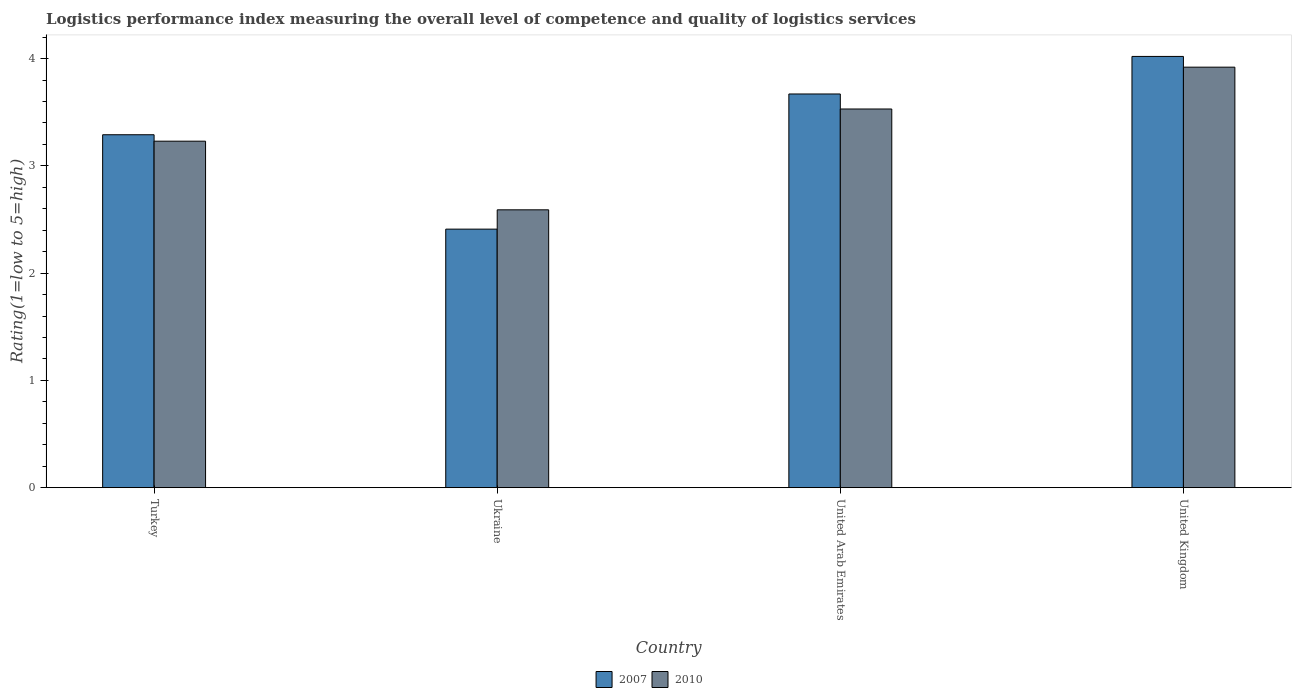How many different coloured bars are there?
Keep it short and to the point. 2. How many groups of bars are there?
Ensure brevity in your answer.  4. Are the number of bars per tick equal to the number of legend labels?
Give a very brief answer. Yes. How many bars are there on the 3rd tick from the left?
Offer a very short reply. 2. How many bars are there on the 1st tick from the right?
Ensure brevity in your answer.  2. What is the label of the 1st group of bars from the left?
Your answer should be compact. Turkey. In how many cases, is the number of bars for a given country not equal to the number of legend labels?
Your answer should be very brief. 0. What is the Logistic performance index in 2010 in United Kingdom?
Offer a very short reply. 3.92. Across all countries, what is the maximum Logistic performance index in 2007?
Give a very brief answer. 4.02. Across all countries, what is the minimum Logistic performance index in 2010?
Your response must be concise. 2.59. In which country was the Logistic performance index in 2010 maximum?
Provide a succinct answer. United Kingdom. In which country was the Logistic performance index in 2010 minimum?
Your response must be concise. Ukraine. What is the total Logistic performance index in 2007 in the graph?
Ensure brevity in your answer.  13.39. What is the difference between the Logistic performance index in 2010 in Turkey and that in United Arab Emirates?
Provide a short and direct response. -0.3. What is the difference between the Logistic performance index in 2010 in Turkey and the Logistic performance index in 2007 in United Kingdom?
Ensure brevity in your answer.  -0.79. What is the average Logistic performance index in 2007 per country?
Make the answer very short. 3.35. What is the difference between the Logistic performance index of/in 2007 and Logistic performance index of/in 2010 in Turkey?
Ensure brevity in your answer.  0.06. In how many countries, is the Logistic performance index in 2010 greater than 3.6?
Give a very brief answer. 1. What is the ratio of the Logistic performance index in 2007 in Ukraine to that in United Kingdom?
Provide a succinct answer. 0.6. Is the Logistic performance index in 2010 in Turkey less than that in United Arab Emirates?
Offer a very short reply. Yes. What is the difference between the highest and the second highest Logistic performance index in 2010?
Keep it short and to the point. -0.39. What is the difference between the highest and the lowest Logistic performance index in 2010?
Ensure brevity in your answer.  1.33. Is the sum of the Logistic performance index in 2010 in Turkey and Ukraine greater than the maximum Logistic performance index in 2007 across all countries?
Give a very brief answer. Yes. What does the 2nd bar from the left in Turkey represents?
Make the answer very short. 2010. What does the 2nd bar from the right in United Kingdom represents?
Offer a very short reply. 2007. How many bars are there?
Provide a succinct answer. 8. Are all the bars in the graph horizontal?
Your answer should be very brief. No. How many legend labels are there?
Keep it short and to the point. 2. How are the legend labels stacked?
Ensure brevity in your answer.  Horizontal. What is the title of the graph?
Your response must be concise. Logistics performance index measuring the overall level of competence and quality of logistics services. Does "1970" appear as one of the legend labels in the graph?
Provide a succinct answer. No. What is the label or title of the X-axis?
Keep it short and to the point. Country. What is the label or title of the Y-axis?
Offer a terse response. Rating(1=low to 5=high). What is the Rating(1=low to 5=high) of 2007 in Turkey?
Keep it short and to the point. 3.29. What is the Rating(1=low to 5=high) of 2010 in Turkey?
Offer a terse response. 3.23. What is the Rating(1=low to 5=high) in 2007 in Ukraine?
Offer a very short reply. 2.41. What is the Rating(1=low to 5=high) in 2010 in Ukraine?
Provide a short and direct response. 2.59. What is the Rating(1=low to 5=high) in 2007 in United Arab Emirates?
Keep it short and to the point. 3.67. What is the Rating(1=low to 5=high) of 2010 in United Arab Emirates?
Offer a very short reply. 3.53. What is the Rating(1=low to 5=high) of 2007 in United Kingdom?
Ensure brevity in your answer.  4.02. What is the Rating(1=low to 5=high) of 2010 in United Kingdom?
Make the answer very short. 3.92. Across all countries, what is the maximum Rating(1=low to 5=high) of 2007?
Provide a short and direct response. 4.02. Across all countries, what is the maximum Rating(1=low to 5=high) in 2010?
Provide a succinct answer. 3.92. Across all countries, what is the minimum Rating(1=low to 5=high) in 2007?
Ensure brevity in your answer.  2.41. Across all countries, what is the minimum Rating(1=low to 5=high) in 2010?
Provide a short and direct response. 2.59. What is the total Rating(1=low to 5=high) of 2007 in the graph?
Offer a very short reply. 13.39. What is the total Rating(1=low to 5=high) in 2010 in the graph?
Keep it short and to the point. 13.27. What is the difference between the Rating(1=low to 5=high) of 2007 in Turkey and that in Ukraine?
Give a very brief answer. 0.88. What is the difference between the Rating(1=low to 5=high) of 2010 in Turkey and that in Ukraine?
Offer a terse response. 0.64. What is the difference between the Rating(1=low to 5=high) of 2007 in Turkey and that in United Arab Emirates?
Your answer should be compact. -0.38. What is the difference between the Rating(1=low to 5=high) in 2007 in Turkey and that in United Kingdom?
Give a very brief answer. -0.73. What is the difference between the Rating(1=low to 5=high) in 2010 in Turkey and that in United Kingdom?
Ensure brevity in your answer.  -0.69. What is the difference between the Rating(1=low to 5=high) of 2007 in Ukraine and that in United Arab Emirates?
Your answer should be compact. -1.26. What is the difference between the Rating(1=low to 5=high) of 2010 in Ukraine and that in United Arab Emirates?
Your response must be concise. -0.94. What is the difference between the Rating(1=low to 5=high) in 2007 in Ukraine and that in United Kingdom?
Provide a succinct answer. -1.61. What is the difference between the Rating(1=low to 5=high) of 2010 in Ukraine and that in United Kingdom?
Your response must be concise. -1.33. What is the difference between the Rating(1=low to 5=high) in 2007 in United Arab Emirates and that in United Kingdom?
Make the answer very short. -0.35. What is the difference between the Rating(1=low to 5=high) in 2010 in United Arab Emirates and that in United Kingdom?
Offer a very short reply. -0.39. What is the difference between the Rating(1=low to 5=high) of 2007 in Turkey and the Rating(1=low to 5=high) of 2010 in Ukraine?
Provide a short and direct response. 0.7. What is the difference between the Rating(1=low to 5=high) in 2007 in Turkey and the Rating(1=low to 5=high) in 2010 in United Arab Emirates?
Make the answer very short. -0.24. What is the difference between the Rating(1=low to 5=high) of 2007 in Turkey and the Rating(1=low to 5=high) of 2010 in United Kingdom?
Offer a terse response. -0.63. What is the difference between the Rating(1=low to 5=high) in 2007 in Ukraine and the Rating(1=low to 5=high) in 2010 in United Arab Emirates?
Give a very brief answer. -1.12. What is the difference between the Rating(1=low to 5=high) in 2007 in Ukraine and the Rating(1=low to 5=high) in 2010 in United Kingdom?
Your answer should be compact. -1.51. What is the difference between the Rating(1=low to 5=high) of 2007 in United Arab Emirates and the Rating(1=low to 5=high) of 2010 in United Kingdom?
Offer a terse response. -0.25. What is the average Rating(1=low to 5=high) in 2007 per country?
Your answer should be compact. 3.35. What is the average Rating(1=low to 5=high) of 2010 per country?
Keep it short and to the point. 3.32. What is the difference between the Rating(1=low to 5=high) in 2007 and Rating(1=low to 5=high) in 2010 in Ukraine?
Your response must be concise. -0.18. What is the difference between the Rating(1=low to 5=high) of 2007 and Rating(1=low to 5=high) of 2010 in United Arab Emirates?
Offer a terse response. 0.14. What is the ratio of the Rating(1=low to 5=high) of 2007 in Turkey to that in Ukraine?
Your answer should be compact. 1.37. What is the ratio of the Rating(1=low to 5=high) of 2010 in Turkey to that in Ukraine?
Offer a very short reply. 1.25. What is the ratio of the Rating(1=low to 5=high) of 2007 in Turkey to that in United Arab Emirates?
Your answer should be compact. 0.9. What is the ratio of the Rating(1=low to 5=high) of 2010 in Turkey to that in United Arab Emirates?
Provide a short and direct response. 0.92. What is the ratio of the Rating(1=low to 5=high) of 2007 in Turkey to that in United Kingdom?
Provide a succinct answer. 0.82. What is the ratio of the Rating(1=low to 5=high) of 2010 in Turkey to that in United Kingdom?
Your response must be concise. 0.82. What is the ratio of the Rating(1=low to 5=high) in 2007 in Ukraine to that in United Arab Emirates?
Keep it short and to the point. 0.66. What is the ratio of the Rating(1=low to 5=high) in 2010 in Ukraine to that in United Arab Emirates?
Offer a very short reply. 0.73. What is the ratio of the Rating(1=low to 5=high) of 2007 in Ukraine to that in United Kingdom?
Offer a very short reply. 0.6. What is the ratio of the Rating(1=low to 5=high) in 2010 in Ukraine to that in United Kingdom?
Offer a terse response. 0.66. What is the ratio of the Rating(1=low to 5=high) in 2007 in United Arab Emirates to that in United Kingdom?
Provide a short and direct response. 0.91. What is the ratio of the Rating(1=low to 5=high) in 2010 in United Arab Emirates to that in United Kingdom?
Offer a very short reply. 0.9. What is the difference between the highest and the second highest Rating(1=low to 5=high) of 2007?
Give a very brief answer. 0.35. What is the difference between the highest and the second highest Rating(1=low to 5=high) in 2010?
Your answer should be very brief. 0.39. What is the difference between the highest and the lowest Rating(1=low to 5=high) of 2007?
Your answer should be very brief. 1.61. What is the difference between the highest and the lowest Rating(1=low to 5=high) of 2010?
Your response must be concise. 1.33. 